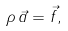Convert formula to latex. <formula><loc_0><loc_0><loc_500><loc_500>\rho \, \vec { a } = \vec { f } ,</formula> 